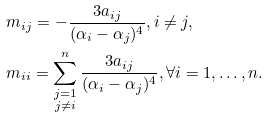<formula> <loc_0><loc_0><loc_500><loc_500>& m _ { i j } = - \frac { 3 a _ { i j } } { ( \alpha _ { i } - \alpha _ { j } ) ^ { 4 } } , i \not = j , \\ & m _ { i i } = \sum ^ { n } _ { \substack { j = 1 \\ j \not = i } } \frac { 3 a _ { i j } } { ( \alpha _ { i } - \alpha _ { j } ) ^ { 4 } } , \forall i = 1 , \dots , n .</formula> 